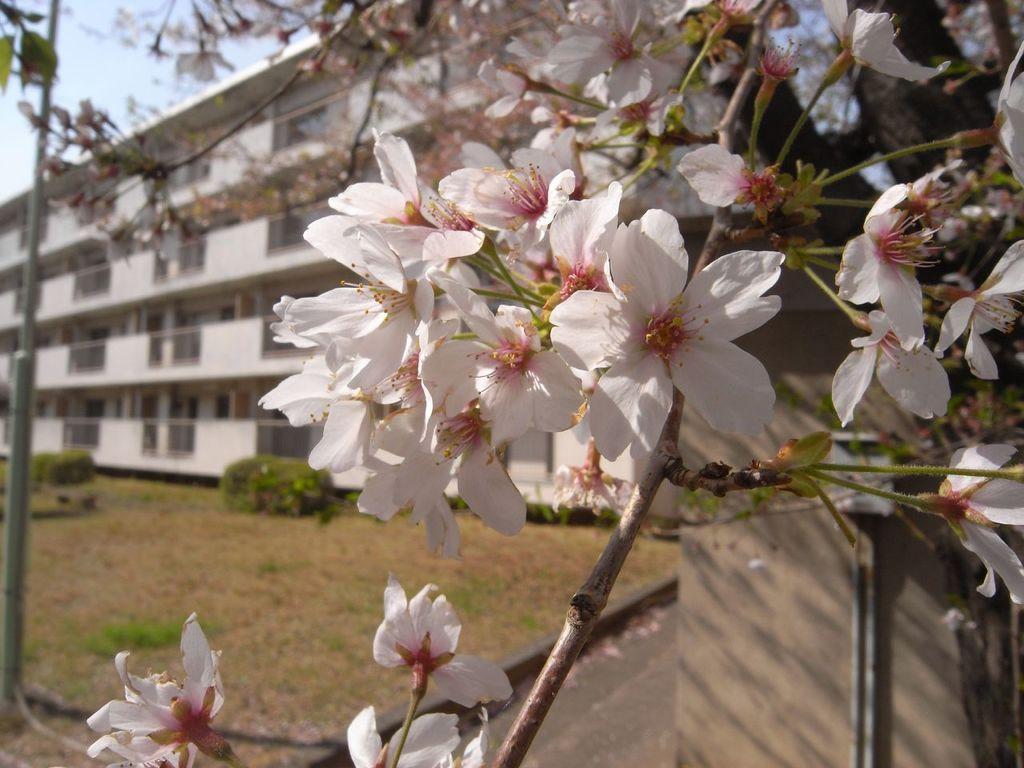Can you describe this image briefly? Here we can see flowers and branches. Background there is a building, pole, plants, wall and sky. 